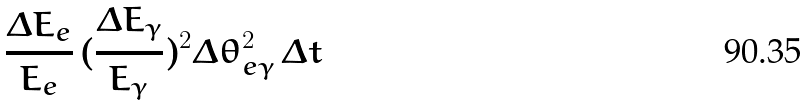Convert formula to latex. <formula><loc_0><loc_0><loc_500><loc_500>\frac { \Delta E _ { e } } { E _ { e } } \, ( \frac { \Delta E _ { \gamma } } { E _ { \gamma } } ) ^ { 2 } \Delta \theta _ { e \gamma } ^ { 2 } \, \Delta t</formula> 